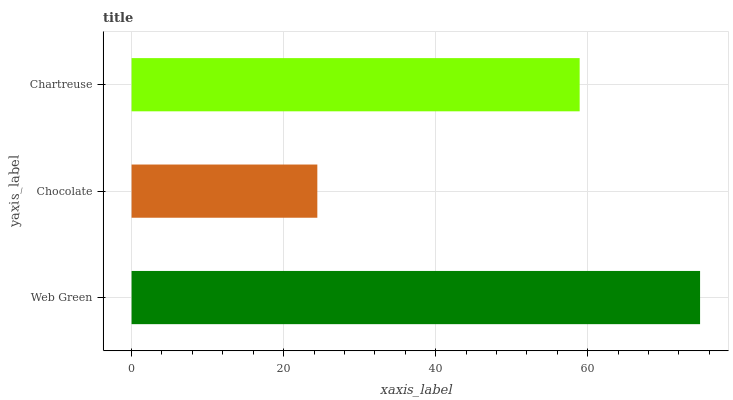Is Chocolate the minimum?
Answer yes or no. Yes. Is Web Green the maximum?
Answer yes or no. Yes. Is Chartreuse the minimum?
Answer yes or no. No. Is Chartreuse the maximum?
Answer yes or no. No. Is Chartreuse greater than Chocolate?
Answer yes or no. Yes. Is Chocolate less than Chartreuse?
Answer yes or no. Yes. Is Chocolate greater than Chartreuse?
Answer yes or no. No. Is Chartreuse less than Chocolate?
Answer yes or no. No. Is Chartreuse the high median?
Answer yes or no. Yes. Is Chartreuse the low median?
Answer yes or no. Yes. Is Web Green the high median?
Answer yes or no. No. Is Chocolate the low median?
Answer yes or no. No. 